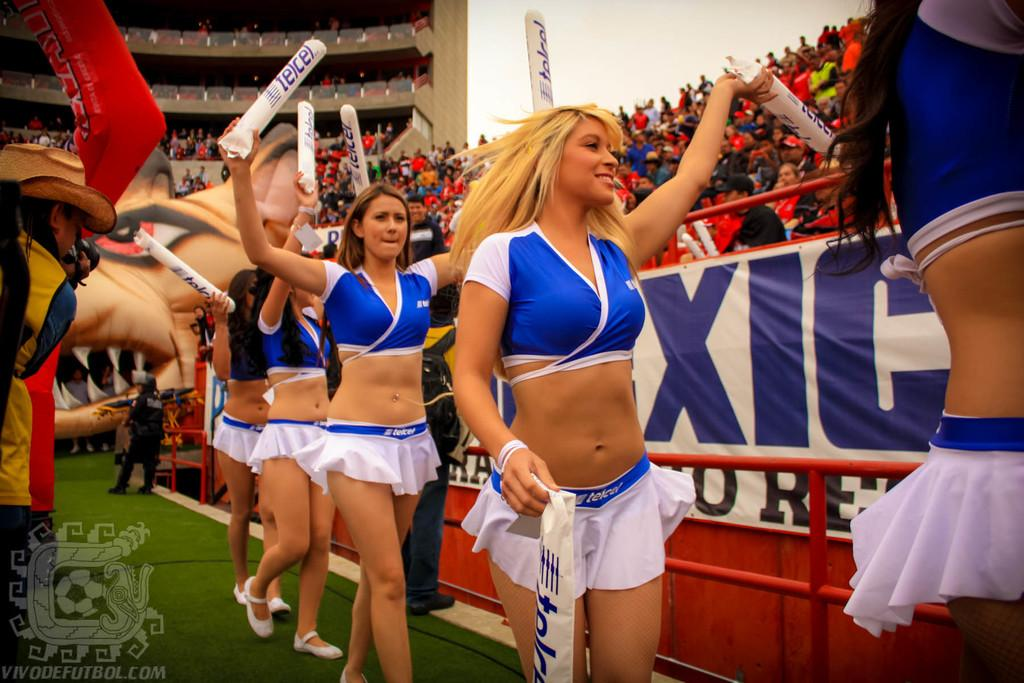Provide a one-sentence caption for the provided image. Cheerleaders in front of a banner with XIC on it. 